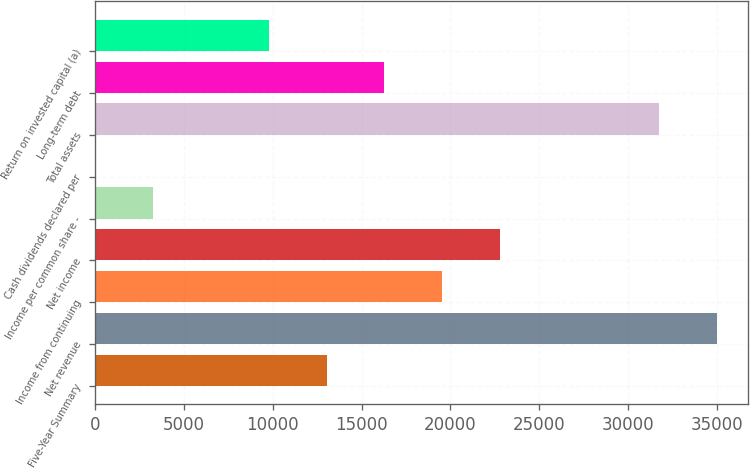Convert chart to OTSL. <chart><loc_0><loc_0><loc_500><loc_500><bar_chart><fcel>Five-Year Summary<fcel>Net revenue<fcel>Income from continuing<fcel>Net income<fcel>Income per common share -<fcel>Cash dividends declared per<fcel>Total assets<fcel>Long-term debt<fcel>Return on invested capital (a)<nl><fcel>13025.4<fcel>34983.1<fcel>19537.6<fcel>22793.7<fcel>3257.11<fcel>1.01<fcel>31727<fcel>16281.5<fcel>9769.31<nl></chart> 